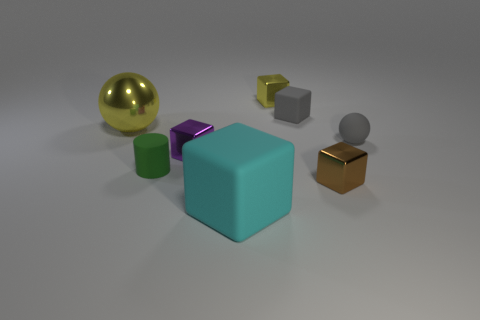Add 1 small gray objects. How many objects exist? 9 Subtract all yellow metal cubes. How many cubes are left? 4 Subtract all yellow balls. How many balls are left? 1 Subtract all cylinders. How many objects are left? 7 Add 3 yellow metal spheres. How many yellow metal spheres are left? 4 Add 2 large rubber objects. How many large rubber objects exist? 3 Subtract 1 green cylinders. How many objects are left? 7 Subtract all red spheres. Subtract all yellow cylinders. How many spheres are left? 2 Subtract all red cylinders. How many purple blocks are left? 1 Subtract all cyan matte objects. Subtract all cyan shiny spheres. How many objects are left? 7 